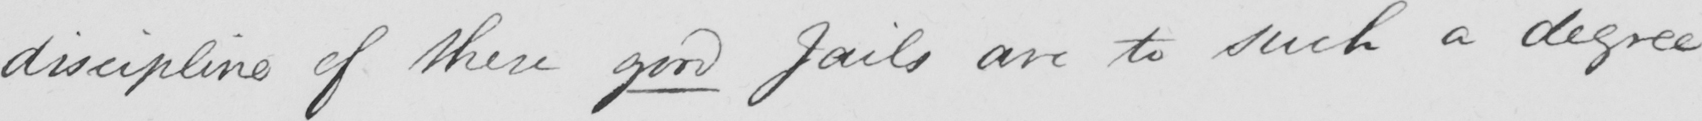What text is written in this handwritten line? discipline of these good jails are to such a degree 